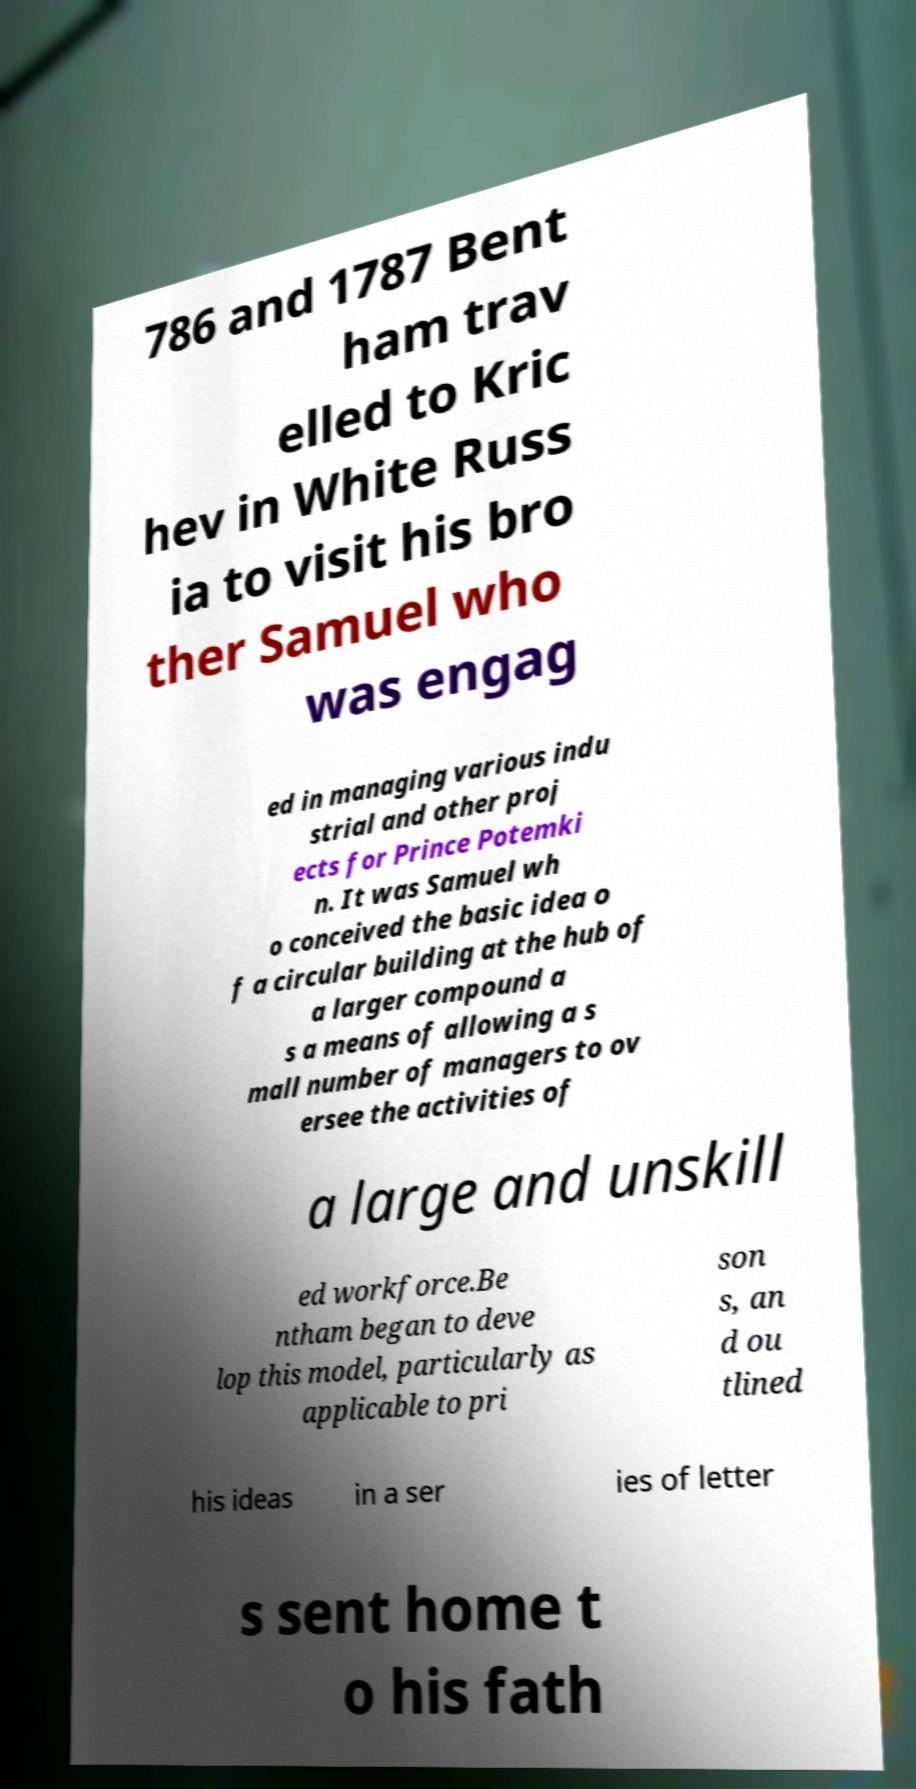Please read and relay the text visible in this image. What does it say? 786 and 1787 Bent ham trav elled to Kric hev in White Russ ia to visit his bro ther Samuel who was engag ed in managing various indu strial and other proj ects for Prince Potemki n. It was Samuel wh o conceived the basic idea o f a circular building at the hub of a larger compound a s a means of allowing a s mall number of managers to ov ersee the activities of a large and unskill ed workforce.Be ntham began to deve lop this model, particularly as applicable to pri son s, an d ou tlined his ideas in a ser ies of letter s sent home t o his fath 